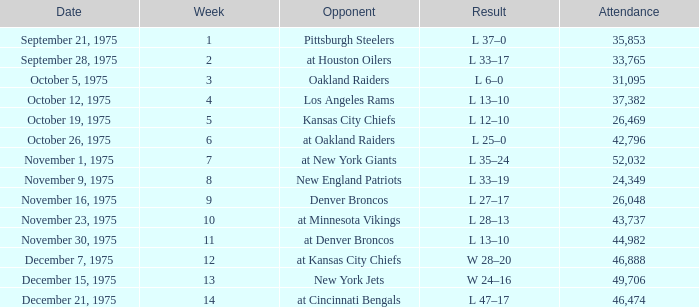What is the average Week when the result was w 28–20, and there were more than 46,888 in attendance? None. Help me parse the entirety of this table. {'header': ['Date', 'Week', 'Opponent', 'Result', 'Attendance'], 'rows': [['September 21, 1975', '1', 'Pittsburgh Steelers', 'L 37–0', '35,853'], ['September 28, 1975', '2', 'at Houston Oilers', 'L 33–17', '33,765'], ['October 5, 1975', '3', 'Oakland Raiders', 'L 6–0', '31,095'], ['October 12, 1975', '4', 'Los Angeles Rams', 'L 13–10', '37,382'], ['October 19, 1975', '5', 'Kansas City Chiefs', 'L 12–10', '26,469'], ['October 26, 1975', '6', 'at Oakland Raiders', 'L 25–0', '42,796'], ['November 1, 1975', '7', 'at New York Giants', 'L 35–24', '52,032'], ['November 9, 1975', '8', 'New England Patriots', 'L 33–19', '24,349'], ['November 16, 1975', '9', 'Denver Broncos', 'L 27–17', '26,048'], ['November 23, 1975', '10', 'at Minnesota Vikings', 'L 28–13', '43,737'], ['November 30, 1975', '11', 'at Denver Broncos', 'L 13–10', '44,982'], ['December 7, 1975', '12', 'at Kansas City Chiefs', 'W 28–20', '46,888'], ['December 15, 1975', '13', 'New York Jets', 'W 24–16', '49,706'], ['December 21, 1975', '14', 'at Cincinnati Bengals', 'L 47–17', '46,474']]} 